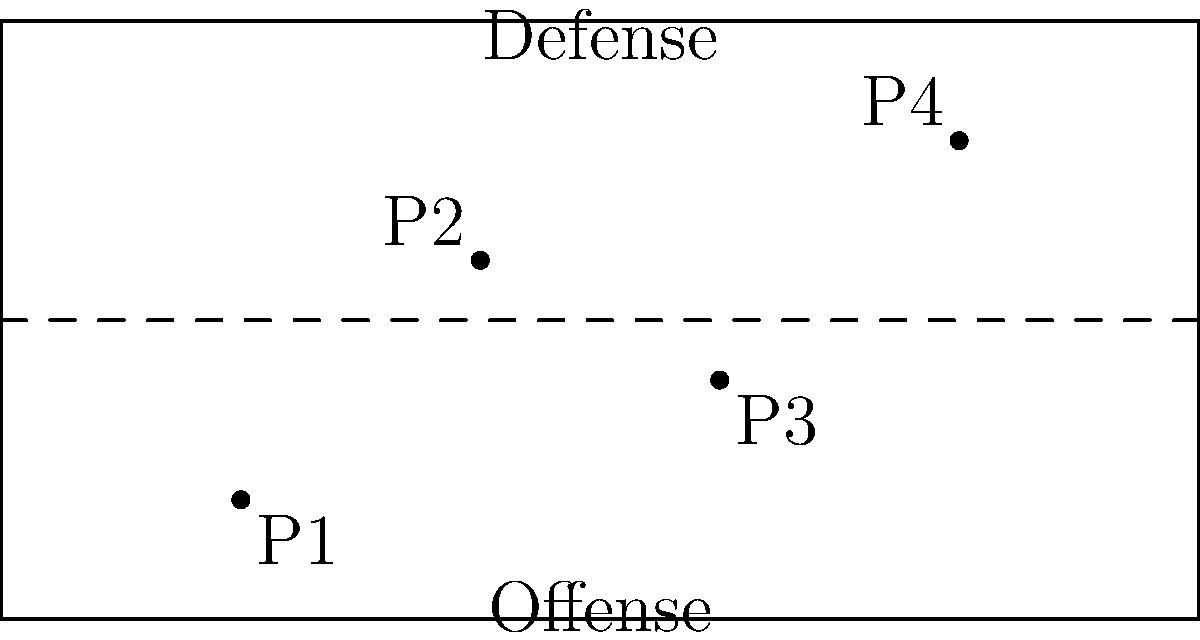In the football field diagram above, four players (P1, P2, P3, and P4) are positioned on either side of the line of scrimmage (dashed line). If the offensive team decides to run a play where P1 and P3 switch positions, and P2 moves to the midpoint between P3's original position and P4, what will be the total distance traveled by all players involved in this movement? To solve this problem, we need to follow these steps:

1. Calculate the distance between P1 and P3:
   P1 coordinates: (20,10)
   P3 coordinates: (60,20)
   Distance = $\sqrt{(60-20)^2 + (20-10)^2} = \sqrt{1600 + 100} = \sqrt{1700} \approx 41.23$ yards

2. Calculate P3's original position to P4:
   P3 coordinates: (60,20)
   P4 coordinates: (80,40)
   Distance = $\sqrt{(80-60)^2 + (40-20)^2} = \sqrt{400 + 400} = \sqrt{800} \approx 28.28$ yards

3. Find the midpoint between P3's original position and P4:
   Midpoint = $(\frac{60+80}{2}, \frac{20+40}{2}) = (70,30)$

4. Calculate the distance P2 needs to travel to the midpoint:
   P2 coordinates: (40,30)
   Midpoint coordinates: (70,30)
   Distance = $\sqrt{(70-40)^2 + (30-30)^2} = \sqrt{900 + 0} = 30$ yards

5. Sum up all the distances:
   Total distance = (P1 to P3) * 2 + (P2 to midpoint)
                  = 41.23 * 2 + 30
                  = 82.46 + 30
                  = 112.46 yards

Therefore, the total distance traveled by all players is approximately 112.46 yards.
Answer: 112.46 yards 